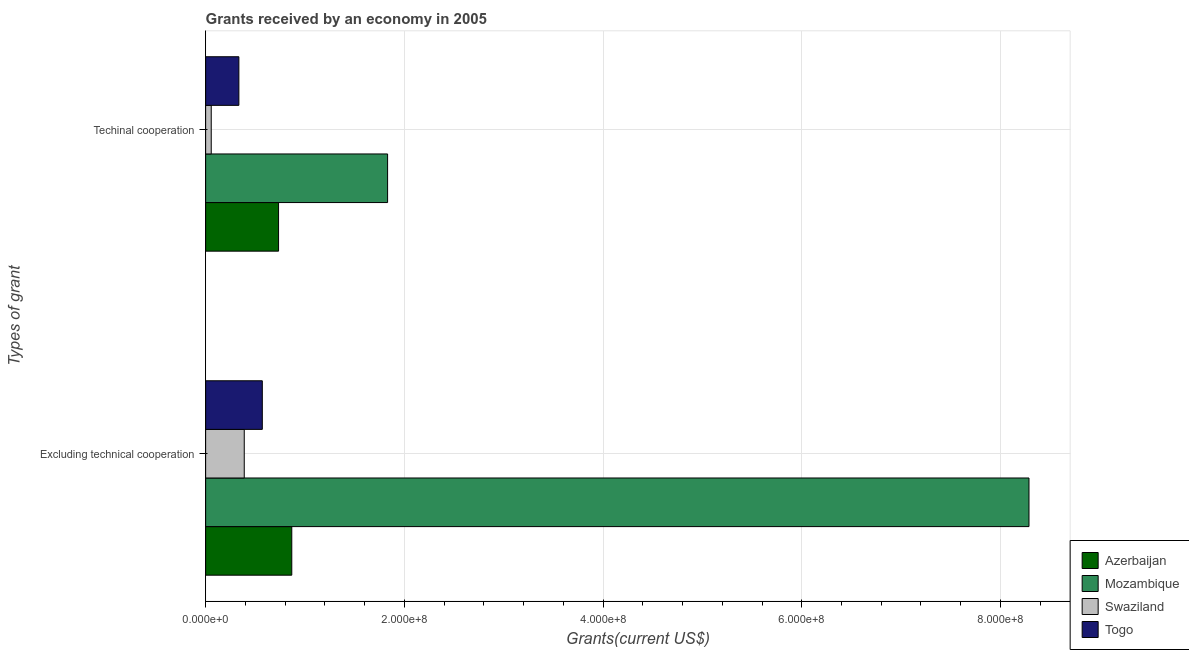How many different coloured bars are there?
Your response must be concise. 4. How many groups of bars are there?
Your answer should be compact. 2. Are the number of bars on each tick of the Y-axis equal?
Your answer should be very brief. Yes. How many bars are there on the 2nd tick from the top?
Provide a short and direct response. 4. How many bars are there on the 1st tick from the bottom?
Make the answer very short. 4. What is the label of the 2nd group of bars from the top?
Offer a terse response. Excluding technical cooperation. What is the amount of grants received(including technical cooperation) in Azerbaijan?
Your answer should be very brief. 7.34e+07. Across all countries, what is the maximum amount of grants received(excluding technical cooperation)?
Your answer should be very brief. 8.29e+08. Across all countries, what is the minimum amount of grants received(including technical cooperation)?
Provide a succinct answer. 5.63e+06. In which country was the amount of grants received(including technical cooperation) maximum?
Keep it short and to the point. Mozambique. In which country was the amount of grants received(excluding technical cooperation) minimum?
Keep it short and to the point. Swaziland. What is the total amount of grants received(including technical cooperation) in the graph?
Offer a terse response. 2.96e+08. What is the difference between the amount of grants received(including technical cooperation) in Azerbaijan and that in Togo?
Your answer should be compact. 4.00e+07. What is the difference between the amount of grants received(excluding technical cooperation) in Mozambique and the amount of grants received(including technical cooperation) in Swaziland?
Keep it short and to the point. 8.23e+08. What is the average amount of grants received(excluding technical cooperation) per country?
Your response must be concise. 2.53e+08. What is the difference between the amount of grants received(including technical cooperation) and amount of grants received(excluding technical cooperation) in Mozambique?
Your answer should be very brief. -6.46e+08. What is the ratio of the amount of grants received(including technical cooperation) in Swaziland to that in Togo?
Offer a very short reply. 0.17. Is the amount of grants received(including technical cooperation) in Azerbaijan less than that in Swaziland?
Offer a terse response. No. In how many countries, is the amount of grants received(excluding technical cooperation) greater than the average amount of grants received(excluding technical cooperation) taken over all countries?
Provide a short and direct response. 1. What does the 1st bar from the top in Excluding technical cooperation represents?
Your answer should be very brief. Togo. What does the 4th bar from the bottom in Techinal cooperation represents?
Offer a terse response. Togo. Are all the bars in the graph horizontal?
Ensure brevity in your answer.  Yes. Does the graph contain any zero values?
Offer a very short reply. No. Does the graph contain grids?
Provide a succinct answer. Yes. How many legend labels are there?
Provide a short and direct response. 4. How are the legend labels stacked?
Your response must be concise. Vertical. What is the title of the graph?
Offer a very short reply. Grants received by an economy in 2005. Does "Lesotho" appear as one of the legend labels in the graph?
Ensure brevity in your answer.  No. What is the label or title of the X-axis?
Your response must be concise. Grants(current US$). What is the label or title of the Y-axis?
Your answer should be compact. Types of grant. What is the Grants(current US$) in Azerbaijan in Excluding technical cooperation?
Ensure brevity in your answer.  8.67e+07. What is the Grants(current US$) in Mozambique in Excluding technical cooperation?
Make the answer very short. 8.29e+08. What is the Grants(current US$) of Swaziland in Excluding technical cooperation?
Give a very brief answer. 3.89e+07. What is the Grants(current US$) in Togo in Excluding technical cooperation?
Offer a terse response. 5.70e+07. What is the Grants(current US$) of Azerbaijan in Techinal cooperation?
Ensure brevity in your answer.  7.34e+07. What is the Grants(current US$) in Mozambique in Techinal cooperation?
Offer a very short reply. 1.83e+08. What is the Grants(current US$) in Swaziland in Techinal cooperation?
Provide a short and direct response. 5.63e+06. What is the Grants(current US$) of Togo in Techinal cooperation?
Keep it short and to the point. 3.35e+07. Across all Types of grant, what is the maximum Grants(current US$) in Azerbaijan?
Your answer should be very brief. 8.67e+07. Across all Types of grant, what is the maximum Grants(current US$) of Mozambique?
Provide a short and direct response. 8.29e+08. Across all Types of grant, what is the maximum Grants(current US$) of Swaziland?
Make the answer very short. 3.89e+07. Across all Types of grant, what is the maximum Grants(current US$) in Togo?
Provide a succinct answer. 5.70e+07. Across all Types of grant, what is the minimum Grants(current US$) of Azerbaijan?
Ensure brevity in your answer.  7.34e+07. Across all Types of grant, what is the minimum Grants(current US$) in Mozambique?
Offer a terse response. 1.83e+08. Across all Types of grant, what is the minimum Grants(current US$) in Swaziland?
Offer a very short reply. 5.63e+06. Across all Types of grant, what is the minimum Grants(current US$) of Togo?
Provide a short and direct response. 3.35e+07. What is the total Grants(current US$) of Azerbaijan in the graph?
Ensure brevity in your answer.  1.60e+08. What is the total Grants(current US$) in Mozambique in the graph?
Keep it short and to the point. 1.01e+09. What is the total Grants(current US$) of Swaziland in the graph?
Provide a succinct answer. 4.45e+07. What is the total Grants(current US$) in Togo in the graph?
Give a very brief answer. 9.05e+07. What is the difference between the Grants(current US$) of Azerbaijan in Excluding technical cooperation and that in Techinal cooperation?
Give a very brief answer. 1.33e+07. What is the difference between the Grants(current US$) of Mozambique in Excluding technical cooperation and that in Techinal cooperation?
Ensure brevity in your answer.  6.46e+08. What is the difference between the Grants(current US$) in Swaziland in Excluding technical cooperation and that in Techinal cooperation?
Provide a succinct answer. 3.32e+07. What is the difference between the Grants(current US$) of Togo in Excluding technical cooperation and that in Techinal cooperation?
Your answer should be very brief. 2.36e+07. What is the difference between the Grants(current US$) of Azerbaijan in Excluding technical cooperation and the Grants(current US$) of Mozambique in Techinal cooperation?
Your response must be concise. -9.64e+07. What is the difference between the Grants(current US$) of Azerbaijan in Excluding technical cooperation and the Grants(current US$) of Swaziland in Techinal cooperation?
Your answer should be compact. 8.11e+07. What is the difference between the Grants(current US$) of Azerbaijan in Excluding technical cooperation and the Grants(current US$) of Togo in Techinal cooperation?
Your answer should be very brief. 5.32e+07. What is the difference between the Grants(current US$) in Mozambique in Excluding technical cooperation and the Grants(current US$) in Swaziland in Techinal cooperation?
Your response must be concise. 8.23e+08. What is the difference between the Grants(current US$) in Mozambique in Excluding technical cooperation and the Grants(current US$) in Togo in Techinal cooperation?
Your answer should be very brief. 7.95e+08. What is the difference between the Grants(current US$) in Swaziland in Excluding technical cooperation and the Grants(current US$) in Togo in Techinal cooperation?
Provide a short and direct response. 5.41e+06. What is the average Grants(current US$) in Azerbaijan per Types of grant?
Ensure brevity in your answer.  8.01e+07. What is the average Grants(current US$) in Mozambique per Types of grant?
Offer a terse response. 5.06e+08. What is the average Grants(current US$) in Swaziland per Types of grant?
Your answer should be compact. 2.22e+07. What is the average Grants(current US$) in Togo per Types of grant?
Your answer should be very brief. 4.53e+07. What is the difference between the Grants(current US$) of Azerbaijan and Grants(current US$) of Mozambique in Excluding technical cooperation?
Your answer should be compact. -7.42e+08. What is the difference between the Grants(current US$) in Azerbaijan and Grants(current US$) in Swaziland in Excluding technical cooperation?
Provide a short and direct response. 4.78e+07. What is the difference between the Grants(current US$) of Azerbaijan and Grants(current US$) of Togo in Excluding technical cooperation?
Your response must be concise. 2.96e+07. What is the difference between the Grants(current US$) of Mozambique and Grants(current US$) of Swaziland in Excluding technical cooperation?
Your answer should be compact. 7.90e+08. What is the difference between the Grants(current US$) of Mozambique and Grants(current US$) of Togo in Excluding technical cooperation?
Offer a terse response. 7.72e+08. What is the difference between the Grants(current US$) of Swaziland and Grants(current US$) of Togo in Excluding technical cooperation?
Provide a succinct answer. -1.82e+07. What is the difference between the Grants(current US$) of Azerbaijan and Grants(current US$) of Mozambique in Techinal cooperation?
Provide a succinct answer. -1.10e+08. What is the difference between the Grants(current US$) of Azerbaijan and Grants(current US$) of Swaziland in Techinal cooperation?
Keep it short and to the point. 6.78e+07. What is the difference between the Grants(current US$) of Azerbaijan and Grants(current US$) of Togo in Techinal cooperation?
Provide a succinct answer. 4.00e+07. What is the difference between the Grants(current US$) in Mozambique and Grants(current US$) in Swaziland in Techinal cooperation?
Your response must be concise. 1.78e+08. What is the difference between the Grants(current US$) of Mozambique and Grants(current US$) of Togo in Techinal cooperation?
Ensure brevity in your answer.  1.50e+08. What is the difference between the Grants(current US$) in Swaziland and Grants(current US$) in Togo in Techinal cooperation?
Make the answer very short. -2.78e+07. What is the ratio of the Grants(current US$) in Azerbaijan in Excluding technical cooperation to that in Techinal cooperation?
Provide a short and direct response. 1.18. What is the ratio of the Grants(current US$) in Mozambique in Excluding technical cooperation to that in Techinal cooperation?
Your answer should be compact. 4.53. What is the ratio of the Grants(current US$) in Swaziland in Excluding technical cooperation to that in Techinal cooperation?
Your answer should be compact. 6.9. What is the ratio of the Grants(current US$) of Togo in Excluding technical cooperation to that in Techinal cooperation?
Your answer should be very brief. 1.71. What is the difference between the highest and the second highest Grants(current US$) in Azerbaijan?
Provide a succinct answer. 1.33e+07. What is the difference between the highest and the second highest Grants(current US$) of Mozambique?
Offer a very short reply. 6.46e+08. What is the difference between the highest and the second highest Grants(current US$) of Swaziland?
Your response must be concise. 3.32e+07. What is the difference between the highest and the second highest Grants(current US$) of Togo?
Offer a very short reply. 2.36e+07. What is the difference between the highest and the lowest Grants(current US$) of Azerbaijan?
Ensure brevity in your answer.  1.33e+07. What is the difference between the highest and the lowest Grants(current US$) in Mozambique?
Provide a succinct answer. 6.46e+08. What is the difference between the highest and the lowest Grants(current US$) in Swaziland?
Provide a succinct answer. 3.32e+07. What is the difference between the highest and the lowest Grants(current US$) in Togo?
Provide a short and direct response. 2.36e+07. 